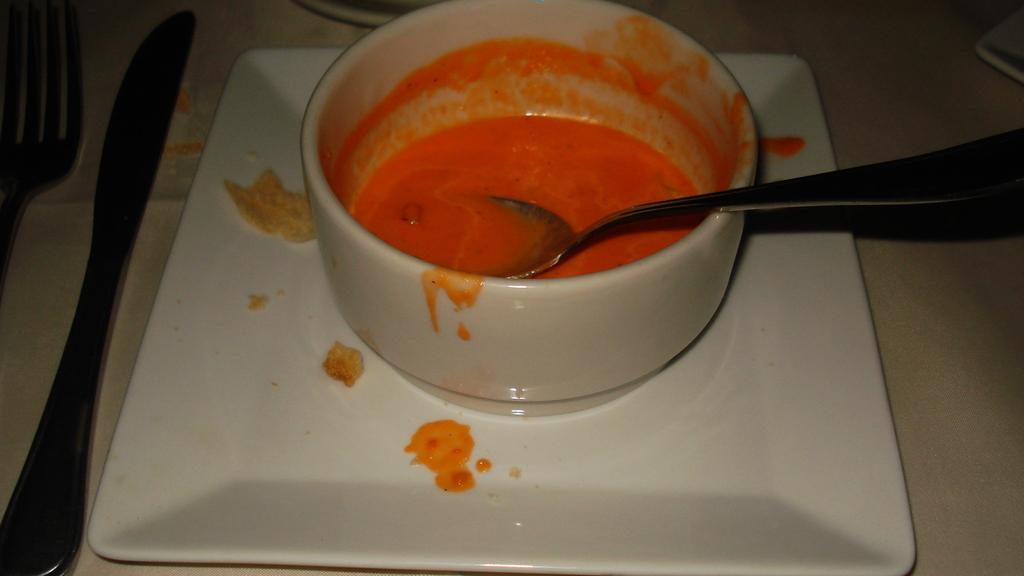What is in the serving bowl that is visible in the image? The serving bowl contains food. How is the serving bowl positioned in the image? The serving bowl is placed on a serving plate. What can be seen in the background of the image? There is a table in the background of the image. What is used for eating that is present on the table? Cutlery is present on the table. What type of underwear is visible on the table in the image? There is no underwear present in the image. How much history can be learned from the dime on the table in the image? There is no dime present in the image, so it cannot be used to learn about history. 